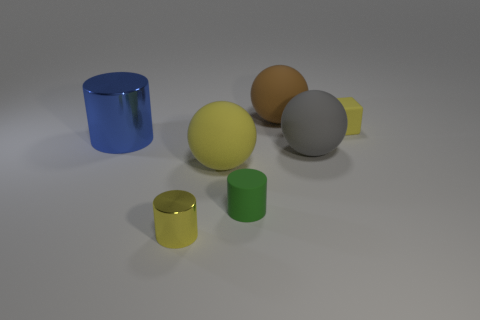Add 2 small red cylinders. How many objects exist? 9 Subtract all balls. How many objects are left? 4 Subtract 0 brown cubes. How many objects are left? 7 Subtract all matte balls. Subtract all large rubber things. How many objects are left? 1 Add 4 blue metallic cylinders. How many blue metallic cylinders are left? 5 Add 1 yellow rubber objects. How many yellow rubber objects exist? 3 